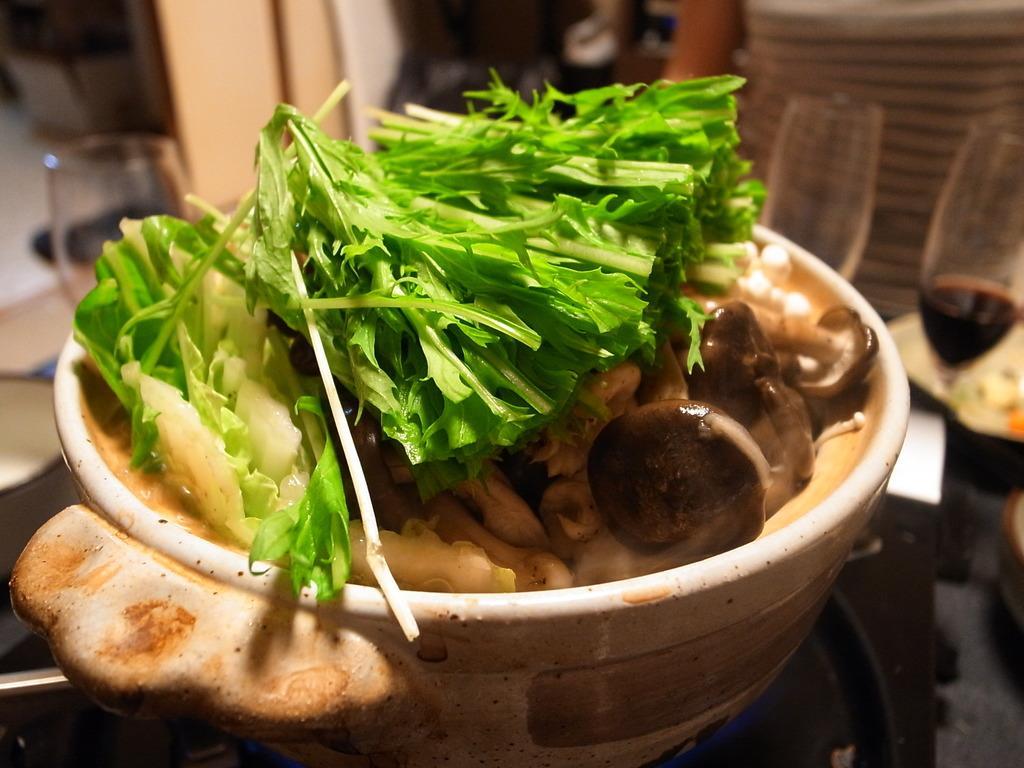Describe this image in one or two sentences. In the image we can see in a bowl there are food items such as boiled mushroom and boiled spinach. Behind there are wine glasses filled with wine and kept on the table. 